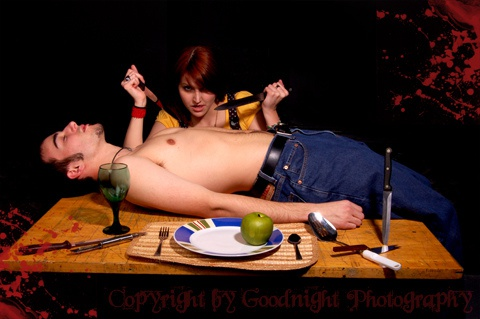Describe the objects in this image and their specific colors. I can see people in black, navy, and salmon tones, dining table in black, brown, maroon, and orange tones, people in black, maroon, brown, and salmon tones, wine glass in black, gray, and maroon tones, and spoon in black, lightgray, maroon, and gray tones in this image. 